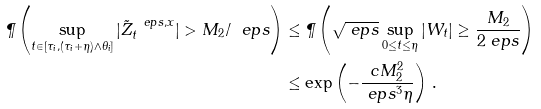Convert formula to latex. <formula><loc_0><loc_0><loc_500><loc_500>\P \left ( \sup _ { t \in [ \tau _ { i } , ( \tau _ { i } + \eta ) \wedge \theta _ { i } ] } | \tilde { Z } _ { t } ^ { \ e p s , x } | > M _ { 2 } / \ e p s \right ) & \leq \P \left ( \sqrt { \ e p s } \sup _ { 0 \leq t \leq \eta } | W _ { t } | \geq \frac { M _ { 2 } } { 2 \ e p s } \right ) \\ & \leq \exp \left ( - \frac { c M _ { 2 } ^ { 2 } } { \ e p s ^ { 3 } \eta } \right ) \, .</formula> 